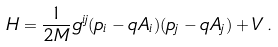Convert formula to latex. <formula><loc_0><loc_0><loc_500><loc_500>H = \frac { 1 } { 2 M } g ^ { i j } ( p _ { i } - q A _ { i } ) ( p _ { j } - q A _ { j } ) + V \, .</formula> 